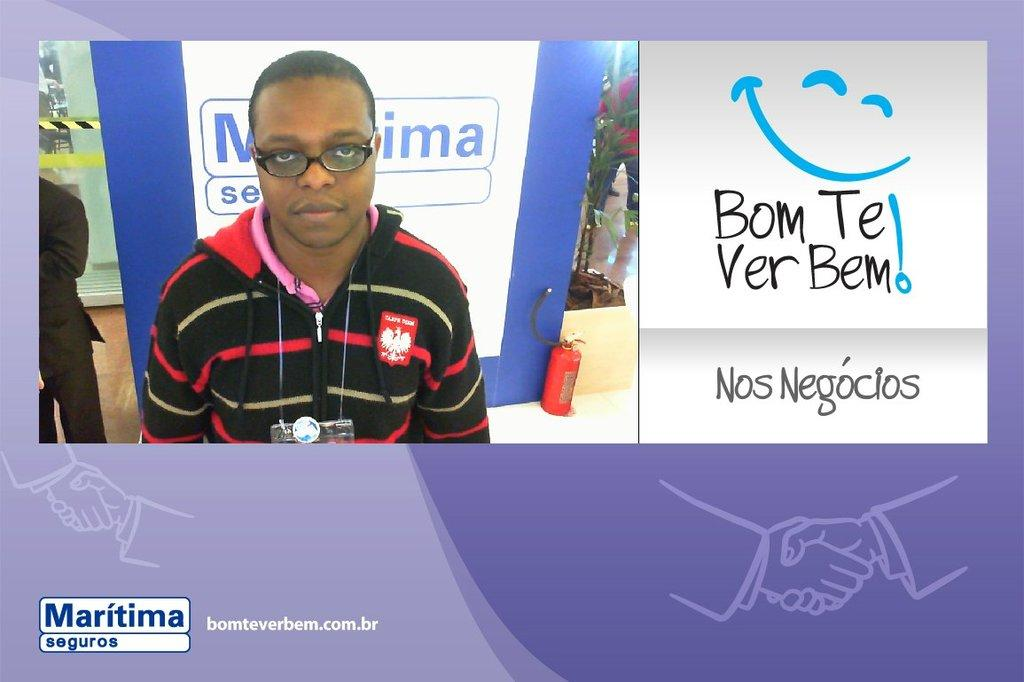What is the main subject in the center of the image? There is a poster in the center of the image. Can you describe the boy on the left side of the image? There is a boy on the left side of the image. What type of protest is the boy participating in on the left side of the image? There is no protest or any indication of a protest in the image; it only features a boy on the left side and a poster in the center. What is the servant doing in the image? There is no servant present in the image. 